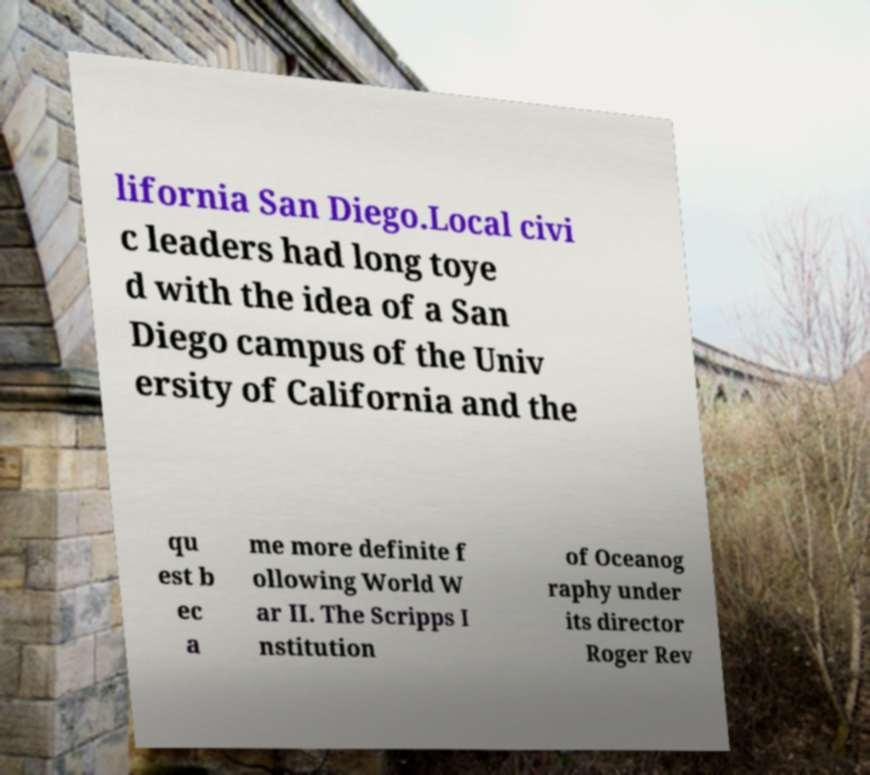I need the written content from this picture converted into text. Can you do that? lifornia San Diego.Local civi c leaders had long toye d with the idea of a San Diego campus of the Univ ersity of California and the qu est b ec a me more definite f ollowing World W ar II. The Scripps I nstitution of Oceanog raphy under its director Roger Rev 